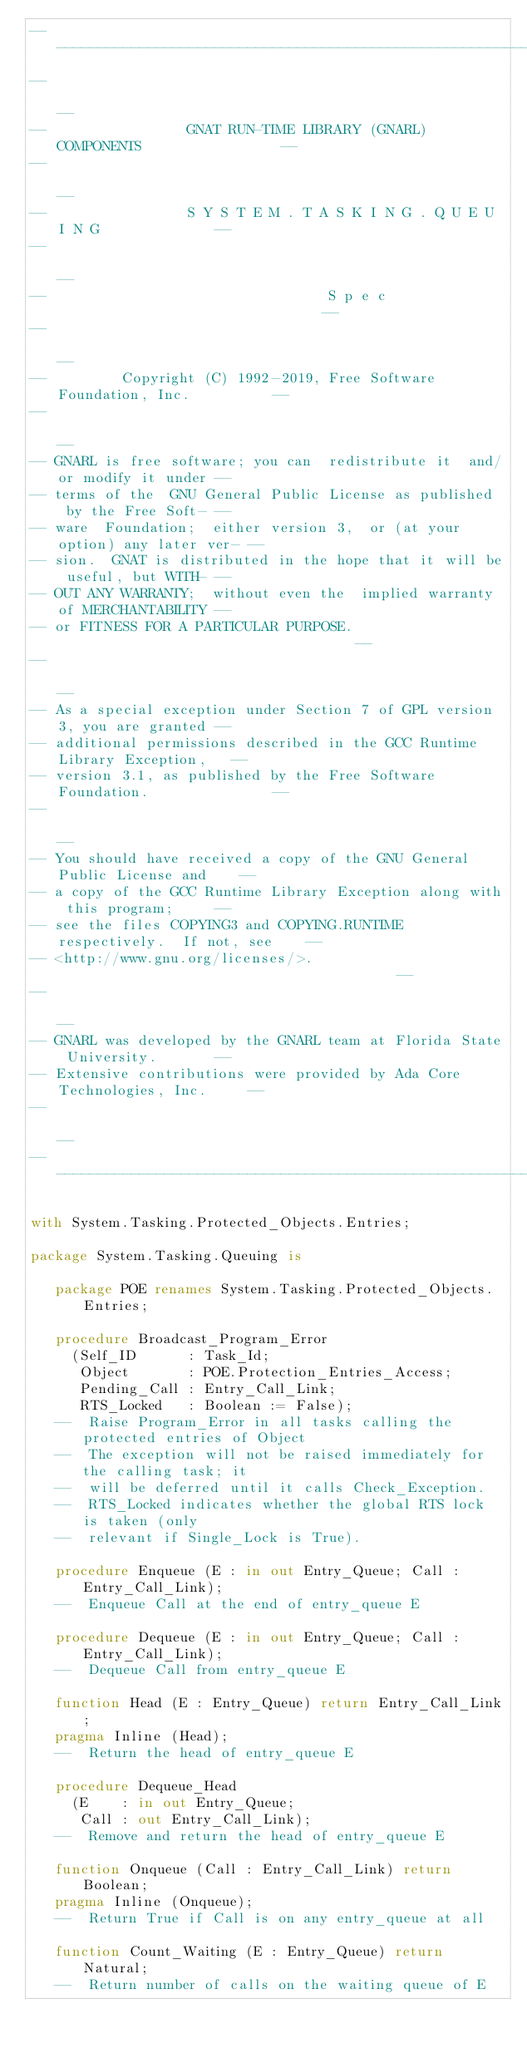<code> <loc_0><loc_0><loc_500><loc_500><_Ada_>------------------------------------------------------------------------------
--                                                                          --
--                 GNAT RUN-TIME LIBRARY (GNARL) COMPONENTS                 --
--                                                                          --
--                 S Y S T E M . T A S K I N G . Q U E U I N G              --
--                                                                          --
--                                  S p e c                                 --
--                                                                          --
--         Copyright (C) 1992-2019, Free Software Foundation, Inc.          --
--                                                                          --
-- GNARL is free software; you can  redistribute it  and/or modify it under --
-- terms of the  GNU General Public License as published  by the Free Soft- --
-- ware  Foundation;  either version 3,  or (at your option) any later ver- --
-- sion.  GNAT is distributed in the hope that it will be useful, but WITH- --
-- OUT ANY WARRANTY;  without even the  implied warranty of MERCHANTABILITY --
-- or FITNESS FOR A PARTICULAR PURPOSE.                                     --
--                                                                          --
-- As a special exception under Section 7 of GPL version 3, you are granted --
-- additional permissions described in the GCC Runtime Library Exception,   --
-- version 3.1, as published by the Free Software Foundation.               --
--                                                                          --
-- You should have received a copy of the GNU General Public License and    --
-- a copy of the GCC Runtime Library Exception along with this program;     --
-- see the files COPYING3 and COPYING.RUNTIME respectively.  If not, see    --
-- <http://www.gnu.org/licenses/>.                                          --
--                                                                          --
-- GNARL was developed by the GNARL team at Florida State University.       --
-- Extensive contributions were provided by Ada Core Technologies, Inc.     --
--                                                                          --
------------------------------------------------------------------------------

with System.Tasking.Protected_Objects.Entries;

package System.Tasking.Queuing is

   package POE renames System.Tasking.Protected_Objects.Entries;

   procedure Broadcast_Program_Error
     (Self_ID      : Task_Id;
      Object       : POE.Protection_Entries_Access;
      Pending_Call : Entry_Call_Link;
      RTS_Locked   : Boolean := False);
   --  Raise Program_Error in all tasks calling the protected entries of Object
   --  The exception will not be raised immediately for the calling task; it
   --  will be deferred until it calls Check_Exception.
   --  RTS_Locked indicates whether the global RTS lock is taken (only
   --  relevant if Single_Lock is True).

   procedure Enqueue (E : in out Entry_Queue; Call : Entry_Call_Link);
   --  Enqueue Call at the end of entry_queue E

   procedure Dequeue (E : in out Entry_Queue; Call : Entry_Call_Link);
   --  Dequeue Call from entry_queue E

   function Head (E : Entry_Queue) return Entry_Call_Link;
   pragma Inline (Head);
   --  Return the head of entry_queue E

   procedure Dequeue_Head
     (E    : in out Entry_Queue;
      Call : out Entry_Call_Link);
   --  Remove and return the head of entry_queue E

   function Onqueue (Call : Entry_Call_Link) return Boolean;
   pragma Inline (Onqueue);
   --  Return True if Call is on any entry_queue at all

   function Count_Waiting (E : Entry_Queue) return Natural;
   --  Return number of calls on the waiting queue of E
</code> 